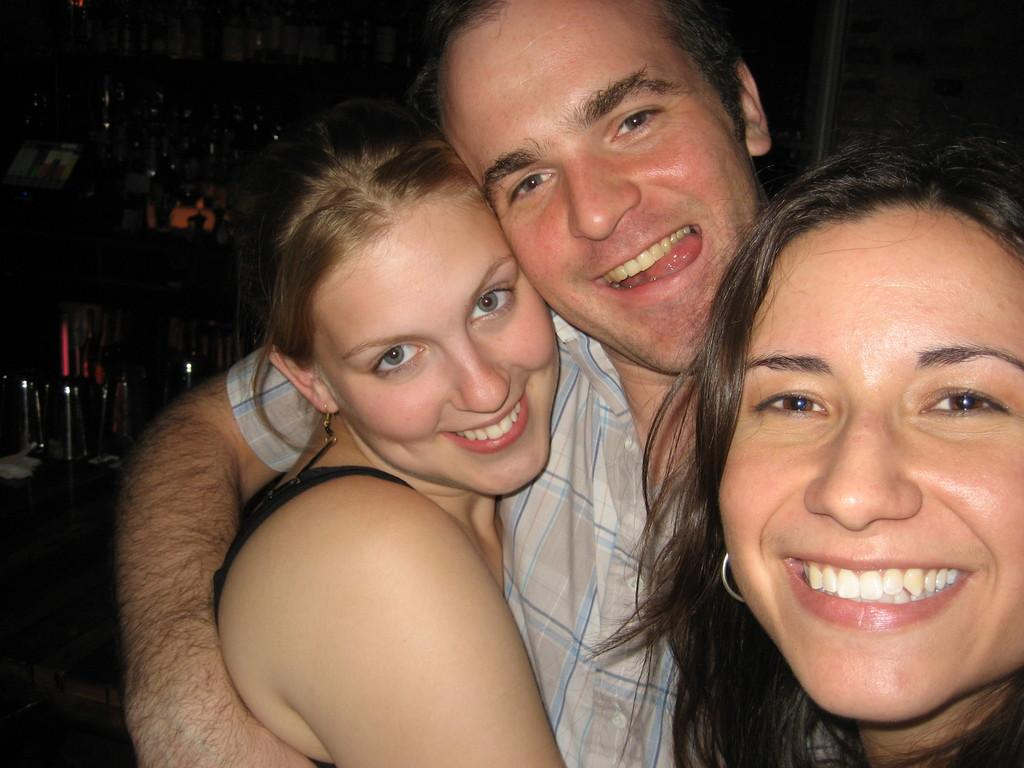How many people are in the image? There are three persons standing in the middle of the image. What are the people in the image doing? The persons are smiling. Can you describe the background of the image? The background of the image is blurred. What type of material is the quiver made of in the image? There is no quiver present in the image. How does the rubbing of the hands affect the image? There is no rubbing of hands depicted in the image. 